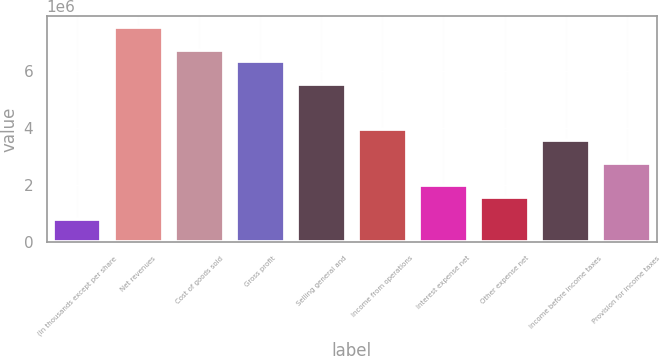<chart> <loc_0><loc_0><loc_500><loc_500><bar_chart><fcel>(In thousands except per share<fcel>Net revenues<fcel>Cost of goods sold<fcel>Gross profit<fcel>Selling general and<fcel>Income from operations<fcel>Interest expense net<fcel>Other expense net<fcel>Income before income taxes<fcel>Provision for income taxes<nl><fcel>792663<fcel>7.53029e+06<fcel>6.73763e+06<fcel>6.3413e+06<fcel>5.54864e+06<fcel>3.96331e+06<fcel>1.98166e+06<fcel>1.58533e+06<fcel>3.56698e+06<fcel>2.77432e+06<nl></chart> 